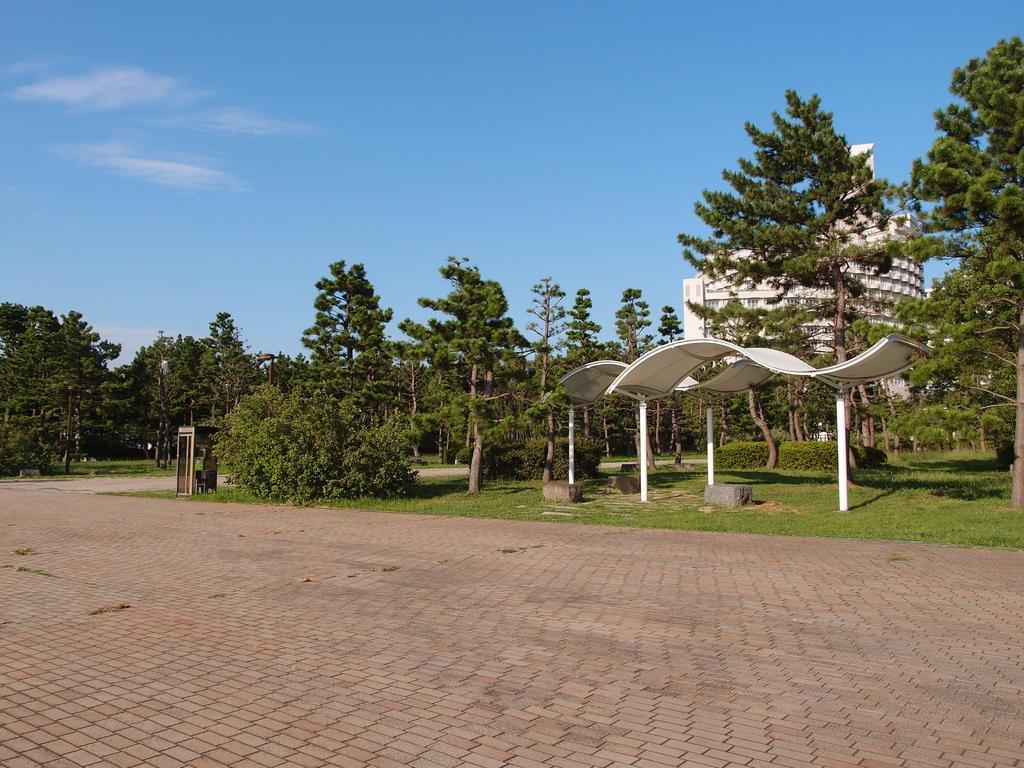Describe this image in one or two sentences. In this image we can see some trees, plants, stones, grass, sheds and a building, in the background we can see the sky with clouds. 